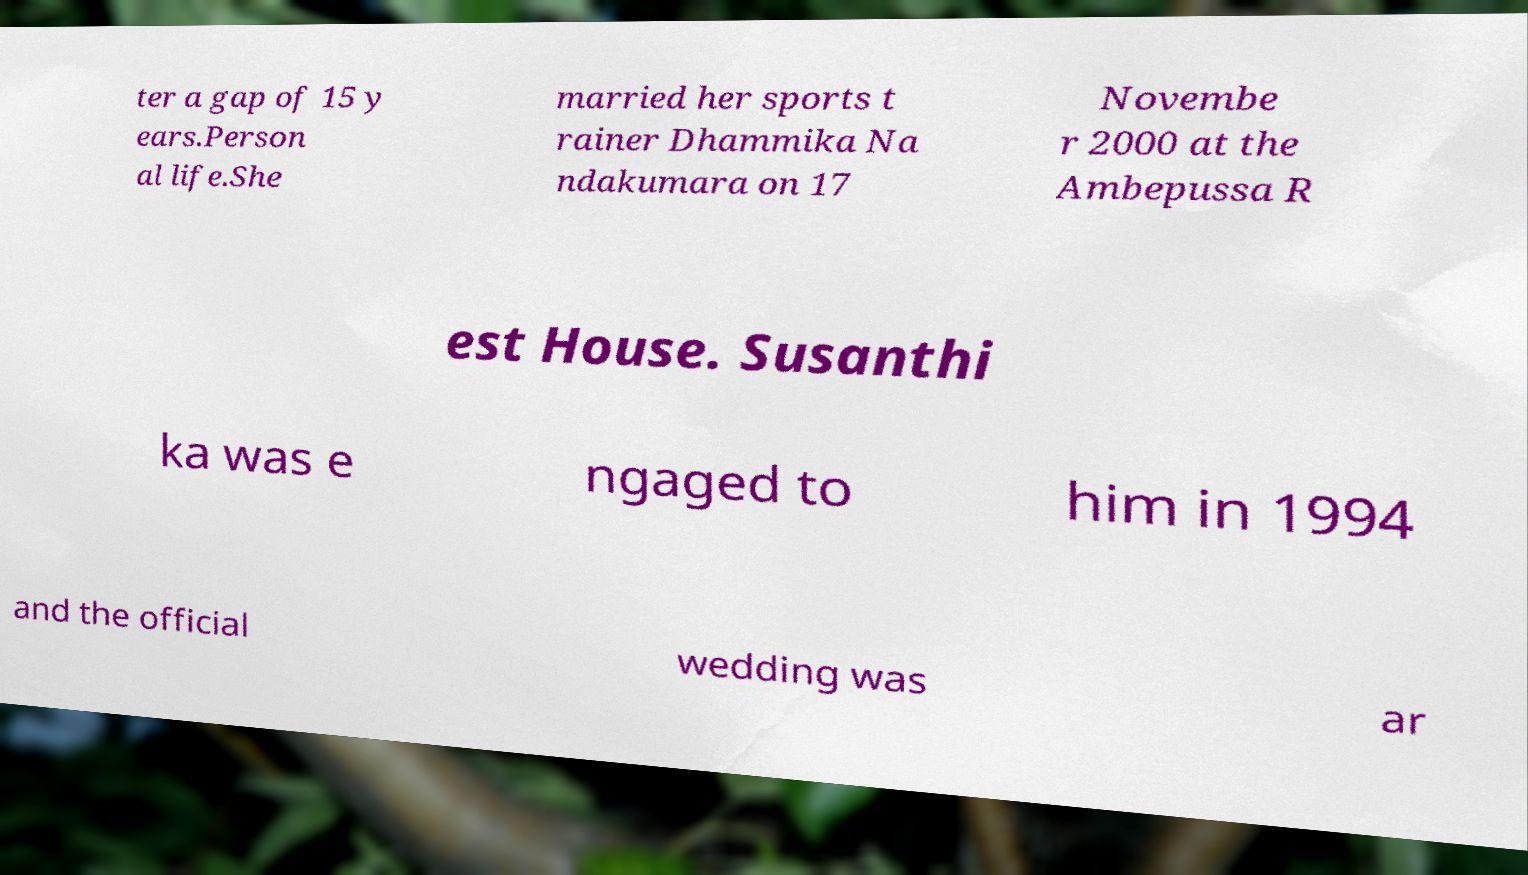What messages or text are displayed in this image? I need them in a readable, typed format. ter a gap of 15 y ears.Person al life.She married her sports t rainer Dhammika Na ndakumara on 17 Novembe r 2000 at the Ambepussa R est House. Susanthi ka was e ngaged to him in 1994 and the official wedding was ar 